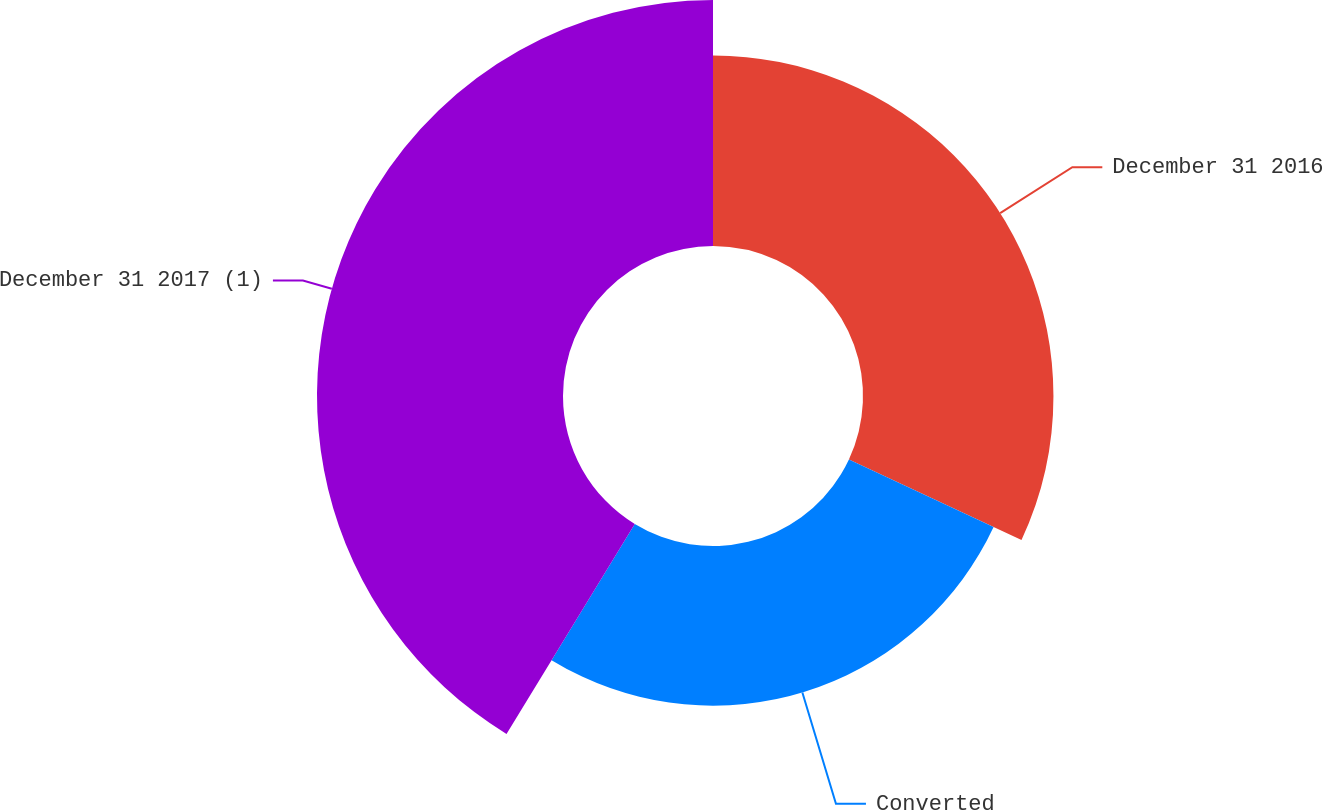Convert chart. <chart><loc_0><loc_0><loc_500><loc_500><pie_chart><fcel>December 31 2016<fcel>Converted<fcel>December 31 2017 (1)<nl><fcel>31.95%<fcel>26.78%<fcel>41.27%<nl></chart> 